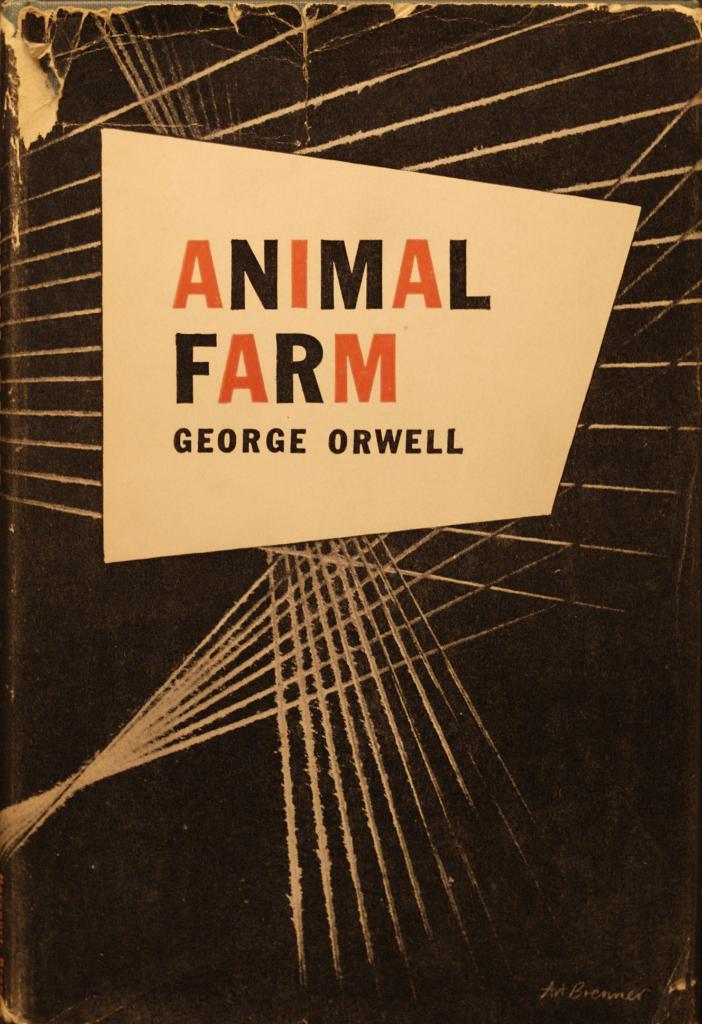Who authored animal farm?
Offer a very short reply. George orwell. 